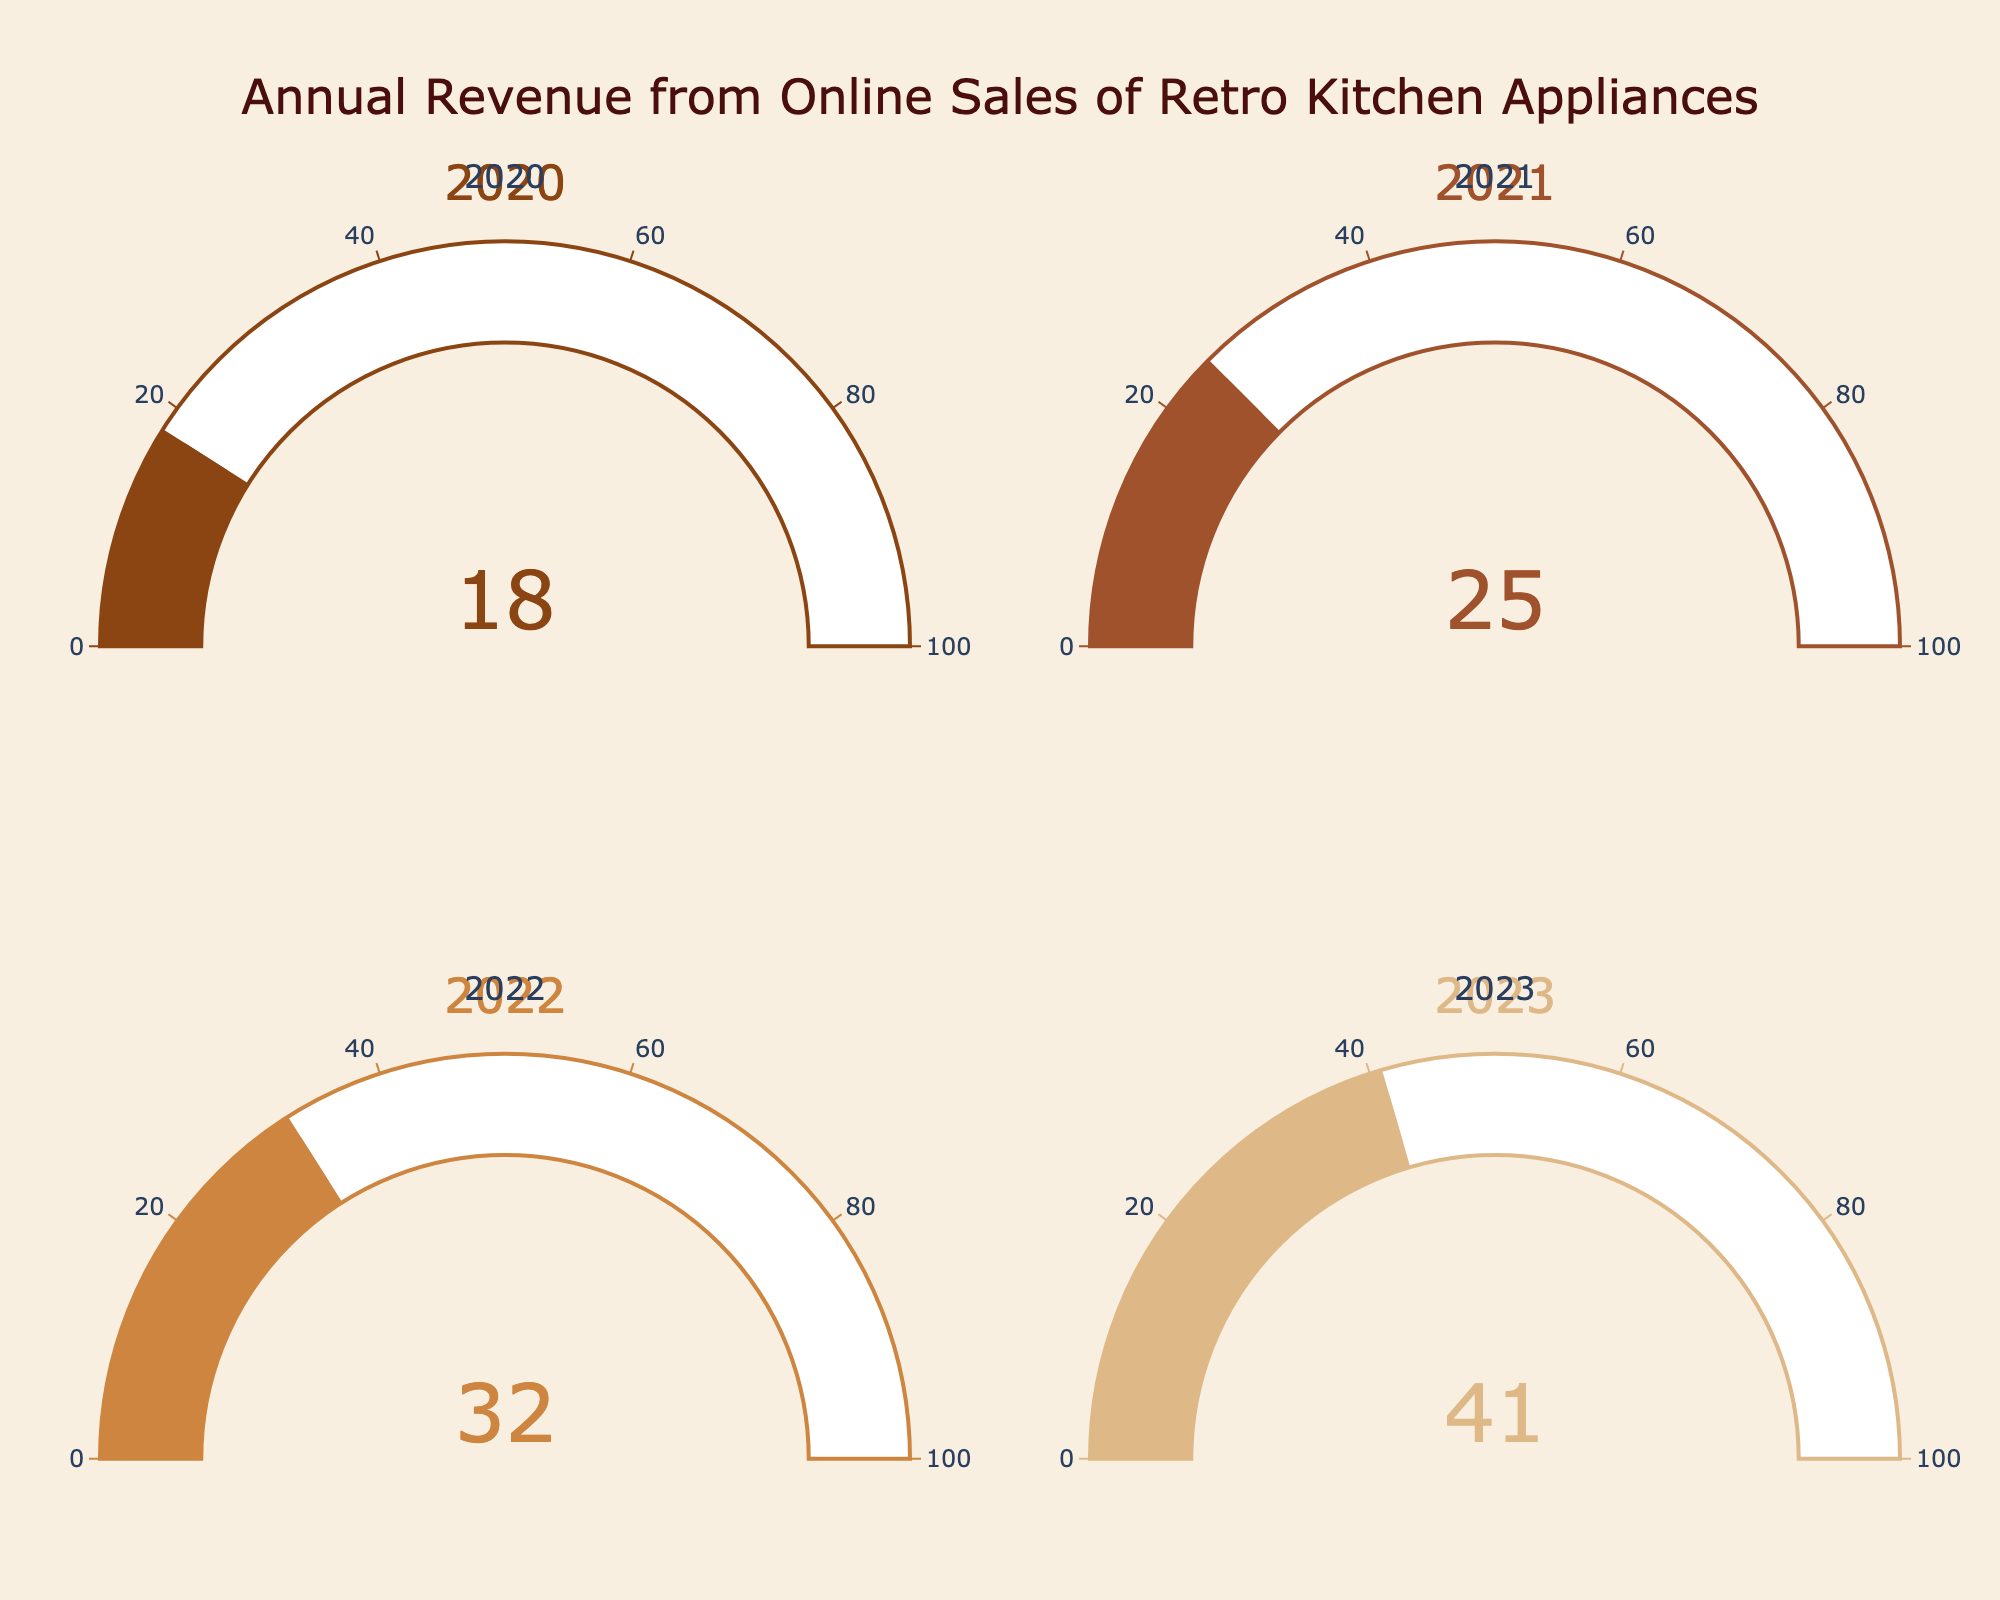What is the title of the figure? The figure's title is displayed at the top and provides a short description of what the chart illustrates. It is written in a larger font size for emphasis. In this figure, the title is "Annual Revenue from Online Sales of Retro Kitchen Appliances."
Answer: Annual Revenue from Online Sales of Retro Kitchen Appliances How many gauge charts are displayed in the figure? The figure uses subplots to display multiple gauge charts. By observing the layout, it is evident there are four gauges presented, one for each year.
Answer: Four Which year had the highest percentage of annual revenue generated from online sales? To find the year with the highest percentage, examine the values displayed on the gauge charts. The highest number among 18, 25, 32, and 41 is 41, which corresponds to the year 2023.
Answer: 2023 What is the color of the gauge in the year 2020? Each gauge chart is colored differently for easy distinction. The gauge chart for the year 2020 uses a color that resembles brown.
Answer: Brown By how much did the percentage of annual revenue from online sales increase from 2021 to 2023? First, find the percentage for 2021 and 2023, which are 25% and 41%, respectively. The mathematical operation to perform here is a subtraction to find the increase: 41% - 25%.
Answer: 16% What is the average percentage of annual revenue generated from online sales over the four years? Add the percentages for the years 2020, 2021, 2022, and 2023, and then divide by 4. The sum of 18 + 25 + 32 + 41 equals 116. Dividing by 4 gives an average of 116 / 4.
Answer: 29% Which year had the lower percentage of online sales revenue, 2020 or 2022? Compare the values displayed on the gauge charts for 2020 and 2022. The value for 2020 is 18%, and for 2022, it is 32%. Since 18% is less than 32%, 2020 had the lower percentage.
Answer: 2020 Has there been a consistent increase in the percentage of online sales from 2020 to 2023? Examine the gauge charts sequentially from 2020 to 2023: 18%, 25%, 32%, and 41%. Each year's percentage is higher than the previous year, indicating a consistent increase.
Answer: Yes What is the combined percentage change of the annual revenue from online sales between 2020 and 2023? To find the combined percentage change, subtract the percentage of 2020 from the percentage of 2023: 41% - 18%.
Answer: 23% 